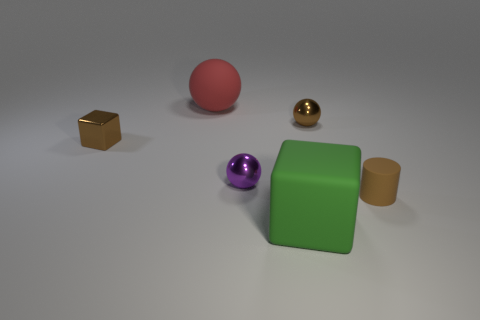There is a metallic object that is the same color as the small cube; what is its shape?
Give a very brief answer. Sphere. There is a big thing to the left of the ball in front of the tiny shiny sphere behind the brown metallic block; what is it made of?
Give a very brief answer. Rubber. How many things are tiny brown matte cylinders or green objects?
Make the answer very short. 2. Is the color of the cube in front of the small brown rubber thing the same as the matte thing behind the small matte cylinder?
Offer a terse response. No. There is a brown rubber object that is the same size as the purple thing; what shape is it?
Your response must be concise. Cylinder. What number of objects are either things in front of the tiny brown matte cylinder or rubber things behind the large green matte thing?
Offer a very short reply. 3. Is the number of rubber balls less than the number of large purple cylinders?
Make the answer very short. No. There is a ball that is the same size as the green matte thing; what is its material?
Keep it short and to the point. Rubber. Does the brown thing behind the small metallic block have the same size as the block on the right side of the big matte ball?
Offer a very short reply. No. Are there any green things that have the same material as the green cube?
Offer a terse response. No. 